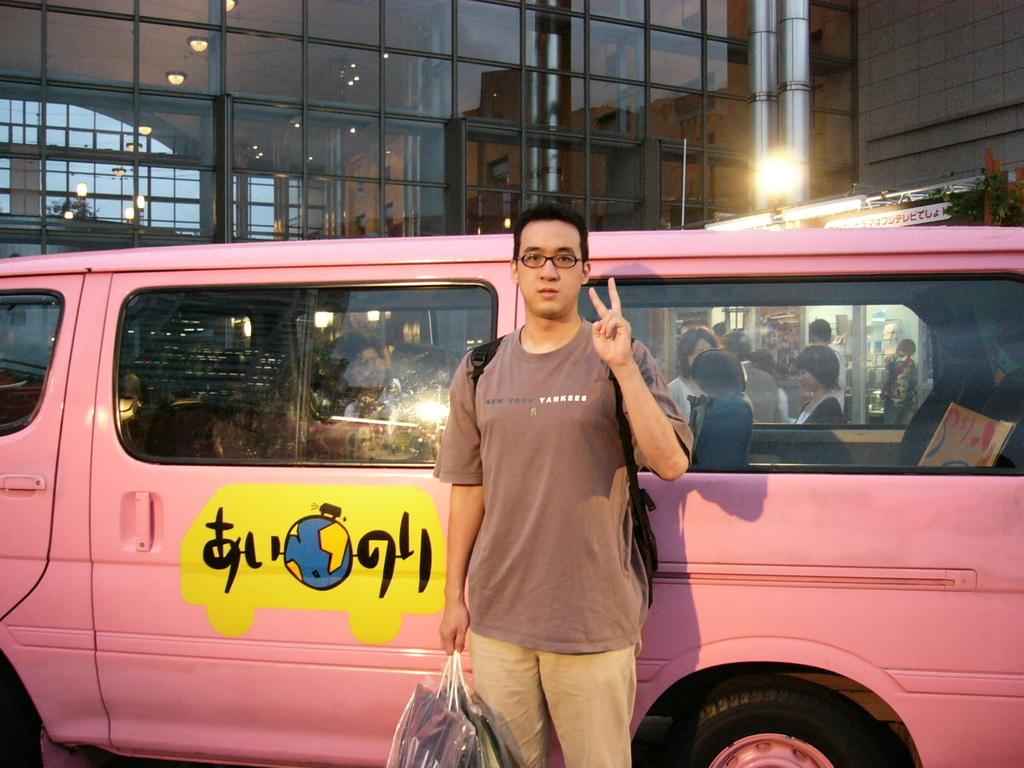<image>
Write a terse but informative summary of the picture. A man is holding up his fingers in the peace sign and in front of a pink van and his shirt says Yankees. 